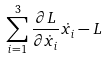<formula> <loc_0><loc_0><loc_500><loc_500>\sum _ { i = 1 } ^ { 3 } \frac { \partial L } { \partial \dot { x } _ { i } } \dot { x _ { i } } - L</formula> 